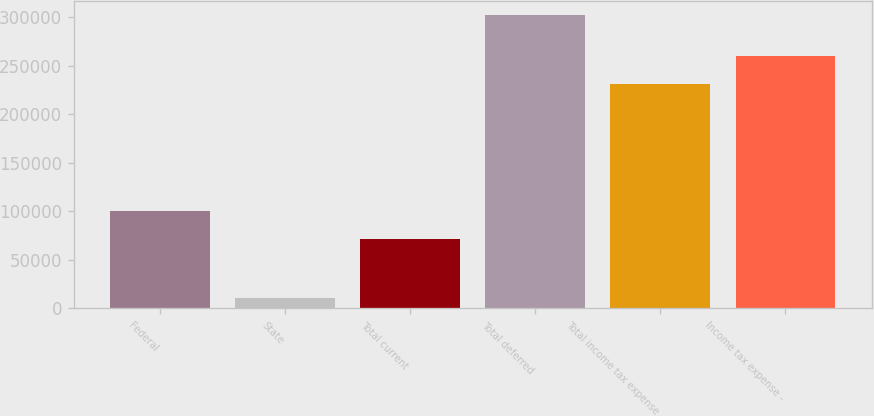<chart> <loc_0><loc_0><loc_500><loc_500><bar_chart><fcel>Federal<fcel>State<fcel>Total current<fcel>Total deferred<fcel>Total income tax expense<fcel>Income tax expense -<nl><fcel>100377<fcel>10537<fcel>71247<fcel>301838<fcel>230591<fcel>259721<nl></chart> 